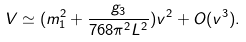<formula> <loc_0><loc_0><loc_500><loc_500>V \simeq ( m _ { 1 } ^ { 2 } + \frac { g _ { 3 } } { 7 6 8 \pi ^ { 2 } L ^ { 2 } } ) v ^ { 2 } + O ( v ^ { 3 } ) .</formula> 